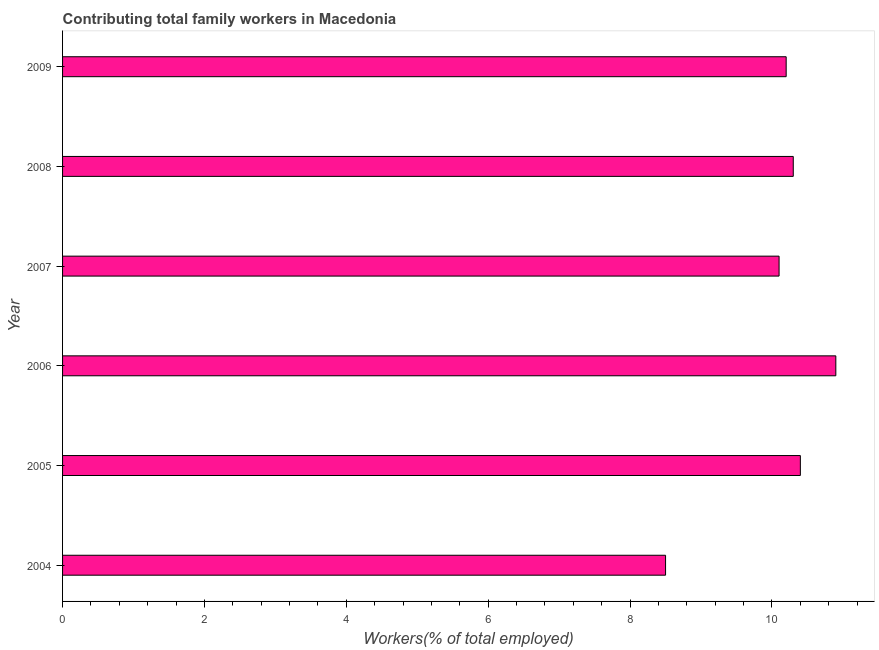Does the graph contain any zero values?
Provide a short and direct response. No. What is the title of the graph?
Ensure brevity in your answer.  Contributing total family workers in Macedonia. What is the label or title of the X-axis?
Keep it short and to the point. Workers(% of total employed). What is the contributing family workers in 2008?
Make the answer very short. 10.3. Across all years, what is the maximum contributing family workers?
Provide a short and direct response. 10.9. Across all years, what is the minimum contributing family workers?
Keep it short and to the point. 8.5. What is the sum of the contributing family workers?
Your response must be concise. 60.4. What is the average contributing family workers per year?
Your answer should be very brief. 10.07. What is the median contributing family workers?
Your answer should be compact. 10.25. What is the ratio of the contributing family workers in 2006 to that in 2009?
Keep it short and to the point. 1.07. What is the difference between the highest and the second highest contributing family workers?
Provide a short and direct response. 0.5. Is the sum of the contributing family workers in 2006 and 2007 greater than the maximum contributing family workers across all years?
Give a very brief answer. Yes. Are all the bars in the graph horizontal?
Provide a short and direct response. Yes. What is the difference between two consecutive major ticks on the X-axis?
Your answer should be compact. 2. Are the values on the major ticks of X-axis written in scientific E-notation?
Give a very brief answer. No. What is the Workers(% of total employed) of 2005?
Your response must be concise. 10.4. What is the Workers(% of total employed) of 2006?
Keep it short and to the point. 10.9. What is the Workers(% of total employed) of 2007?
Provide a succinct answer. 10.1. What is the Workers(% of total employed) in 2008?
Your answer should be compact. 10.3. What is the Workers(% of total employed) of 2009?
Your response must be concise. 10.2. What is the difference between the Workers(% of total employed) in 2004 and 2005?
Provide a short and direct response. -1.9. What is the difference between the Workers(% of total employed) in 2004 and 2007?
Give a very brief answer. -1.6. What is the difference between the Workers(% of total employed) in 2004 and 2008?
Offer a terse response. -1.8. What is the difference between the Workers(% of total employed) in 2004 and 2009?
Your response must be concise. -1.7. What is the difference between the Workers(% of total employed) in 2005 and 2008?
Provide a short and direct response. 0.1. What is the difference between the Workers(% of total employed) in 2005 and 2009?
Keep it short and to the point. 0.2. What is the difference between the Workers(% of total employed) in 2006 and 2007?
Ensure brevity in your answer.  0.8. What is the difference between the Workers(% of total employed) in 2006 and 2009?
Keep it short and to the point. 0.7. What is the difference between the Workers(% of total employed) in 2007 and 2008?
Ensure brevity in your answer.  -0.2. What is the ratio of the Workers(% of total employed) in 2004 to that in 2005?
Provide a short and direct response. 0.82. What is the ratio of the Workers(% of total employed) in 2004 to that in 2006?
Your answer should be very brief. 0.78. What is the ratio of the Workers(% of total employed) in 2004 to that in 2007?
Your answer should be very brief. 0.84. What is the ratio of the Workers(% of total employed) in 2004 to that in 2008?
Your answer should be compact. 0.82. What is the ratio of the Workers(% of total employed) in 2004 to that in 2009?
Ensure brevity in your answer.  0.83. What is the ratio of the Workers(% of total employed) in 2005 to that in 2006?
Your response must be concise. 0.95. What is the ratio of the Workers(% of total employed) in 2006 to that in 2007?
Provide a succinct answer. 1.08. What is the ratio of the Workers(% of total employed) in 2006 to that in 2008?
Your answer should be compact. 1.06. What is the ratio of the Workers(% of total employed) in 2006 to that in 2009?
Your answer should be compact. 1.07. What is the ratio of the Workers(% of total employed) in 2008 to that in 2009?
Offer a very short reply. 1.01. 